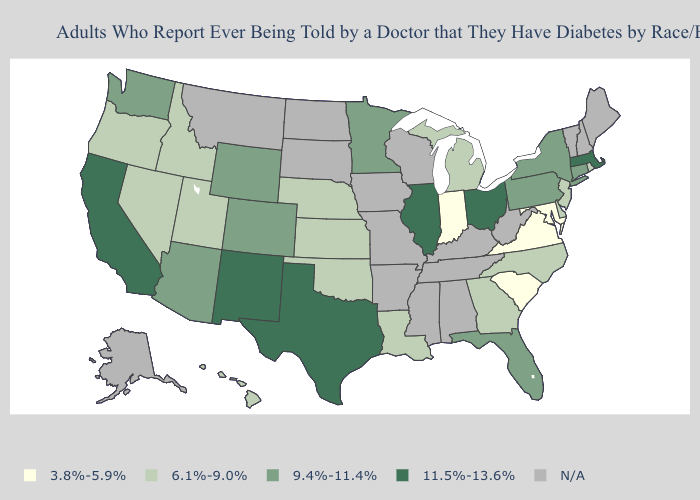Name the states that have a value in the range 9.4%-11.4%?
Be succinct. Arizona, Colorado, Connecticut, Florida, Minnesota, New York, Pennsylvania, Washington, Wyoming. Name the states that have a value in the range N/A?
Concise answer only. Alabama, Alaska, Arkansas, Iowa, Kentucky, Maine, Mississippi, Missouri, Montana, New Hampshire, North Dakota, South Dakota, Tennessee, Vermont, West Virginia, Wisconsin. What is the value of Oregon?
Give a very brief answer. 6.1%-9.0%. Name the states that have a value in the range 3.8%-5.9%?
Be succinct. Indiana, Maryland, South Carolina, Virginia. What is the highest value in states that border Arizona?
Keep it brief. 11.5%-13.6%. Which states have the highest value in the USA?
Give a very brief answer. California, Illinois, Massachusetts, New Mexico, Ohio, Texas. What is the value of Oregon?
Be succinct. 6.1%-9.0%. What is the value of Vermont?
Write a very short answer. N/A. Name the states that have a value in the range N/A?
Short answer required. Alabama, Alaska, Arkansas, Iowa, Kentucky, Maine, Mississippi, Missouri, Montana, New Hampshire, North Dakota, South Dakota, Tennessee, Vermont, West Virginia, Wisconsin. What is the value of Georgia?
Quick response, please. 6.1%-9.0%. Name the states that have a value in the range 3.8%-5.9%?
Write a very short answer. Indiana, Maryland, South Carolina, Virginia. Name the states that have a value in the range 11.5%-13.6%?
Answer briefly. California, Illinois, Massachusetts, New Mexico, Ohio, Texas. What is the value of Rhode Island?
Concise answer only. 6.1%-9.0%. Name the states that have a value in the range 9.4%-11.4%?
Quick response, please. Arizona, Colorado, Connecticut, Florida, Minnesota, New York, Pennsylvania, Washington, Wyoming. 